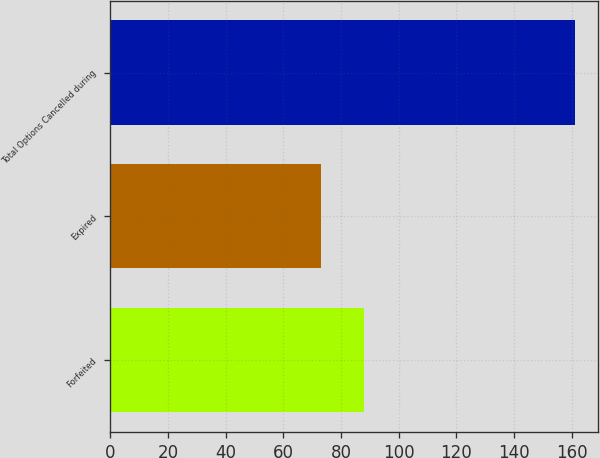Convert chart. <chart><loc_0><loc_0><loc_500><loc_500><bar_chart><fcel>Forfeited<fcel>Expired<fcel>Total Options Cancelled during<nl><fcel>88<fcel>73<fcel>161<nl></chart> 